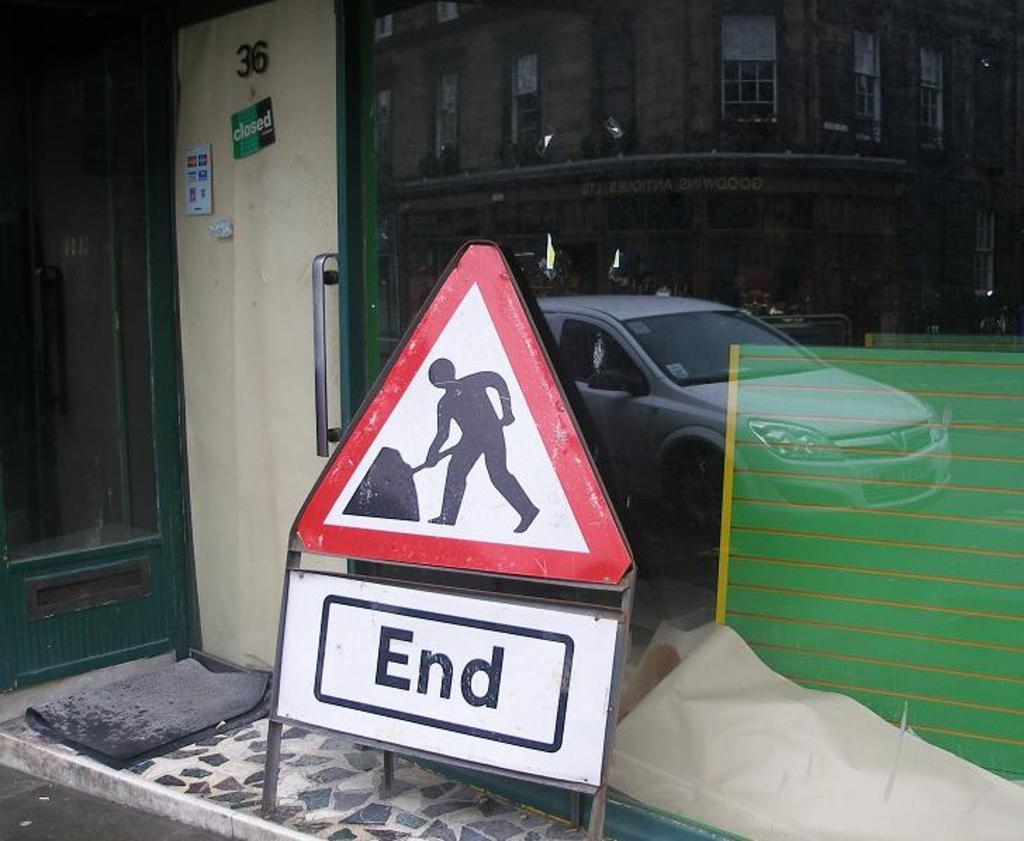<image>
Relay a brief, clear account of the picture shown. A door that has a closed sign on it is next to a sign that says "End". 